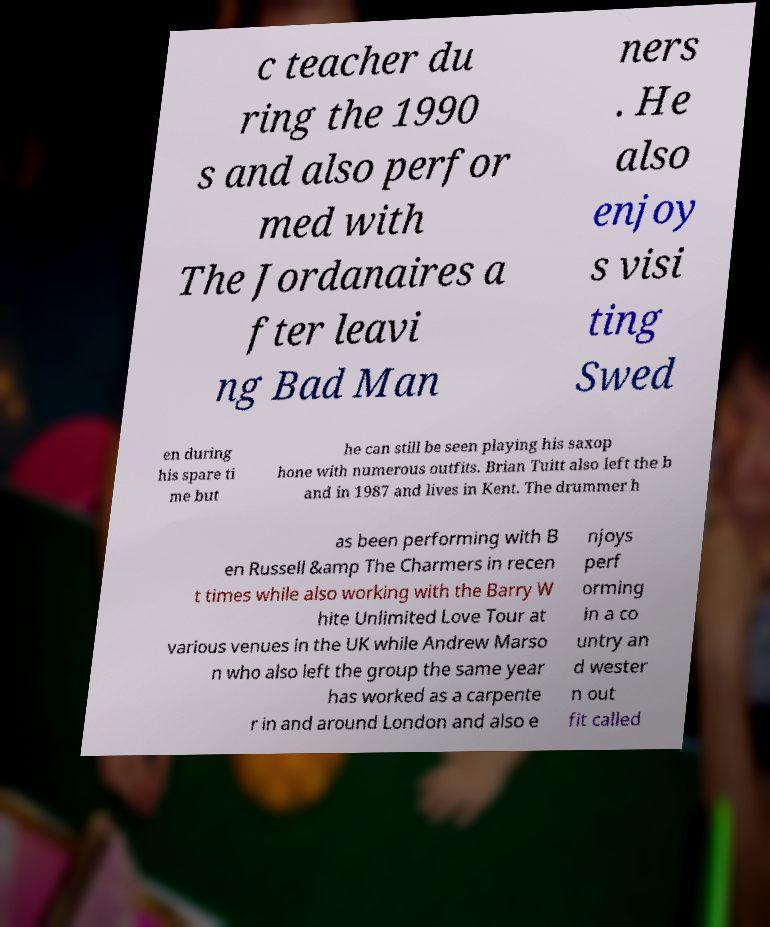For documentation purposes, I need the text within this image transcribed. Could you provide that? c teacher du ring the 1990 s and also perfor med with The Jordanaires a fter leavi ng Bad Man ners . He also enjoy s visi ting Swed en during his spare ti me but he can still be seen playing his saxop hone with numerous outfits. Brian Tuitt also left the b and in 1987 and lives in Kent. The drummer h as been performing with B en Russell &amp The Charmers in recen t times while also working with the Barry W hite Unlimited Love Tour at various venues in the UK while Andrew Marso n who also left the group the same year has worked as a carpente r in and around London and also e njoys perf orming in a co untry an d wester n out fit called 